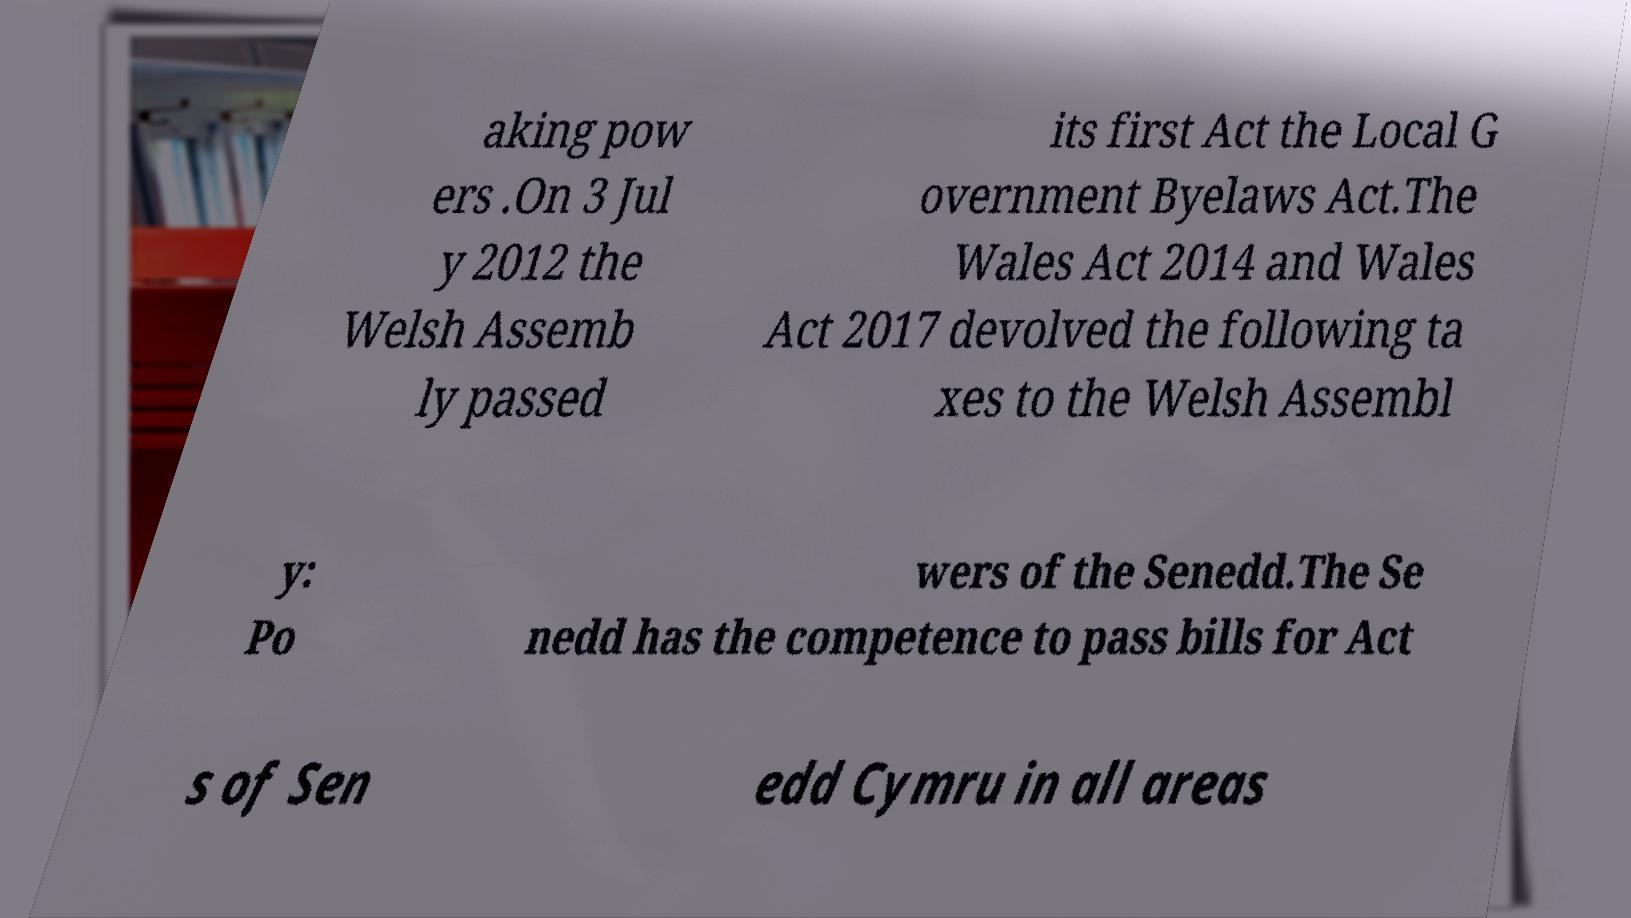I need the written content from this picture converted into text. Can you do that? aking pow ers .On 3 Jul y 2012 the Welsh Assemb ly passed its first Act the Local G overnment Byelaws Act.The Wales Act 2014 and Wales Act 2017 devolved the following ta xes to the Welsh Assembl y: Po wers of the Senedd.The Se nedd has the competence to pass bills for Act s of Sen edd Cymru in all areas 